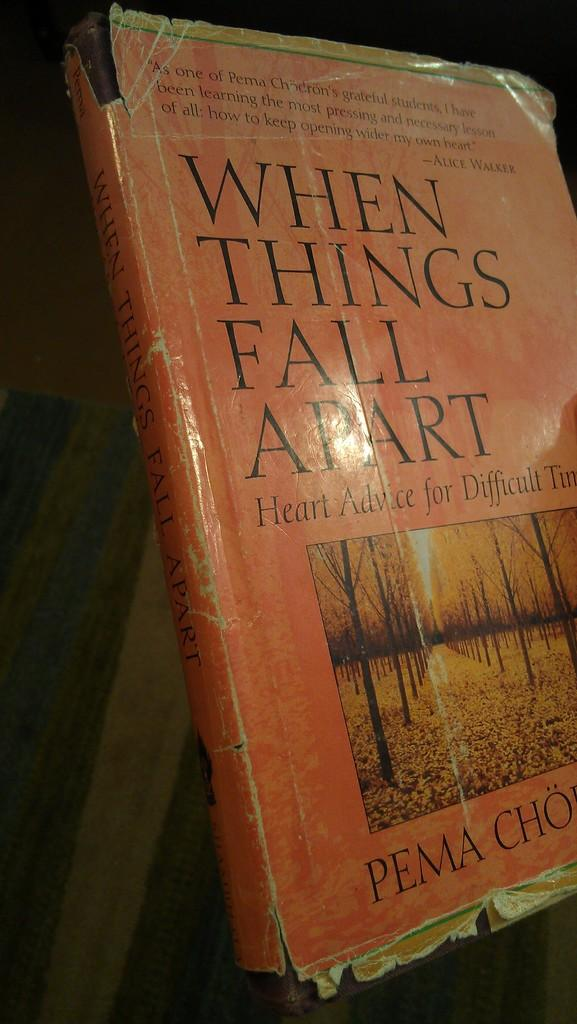What is the main object in the image? There is a book in the image. What can be observed about the book's appearance? The book has an orange cover page. Is there any text on the book's cover page? Yes, there is text written on the cover page. What type of image is depicted on the book? There is a picture of trees on the book. How much income does the airport generate in the image? There is no airport present in the image, so it is not possible to determine its income. 